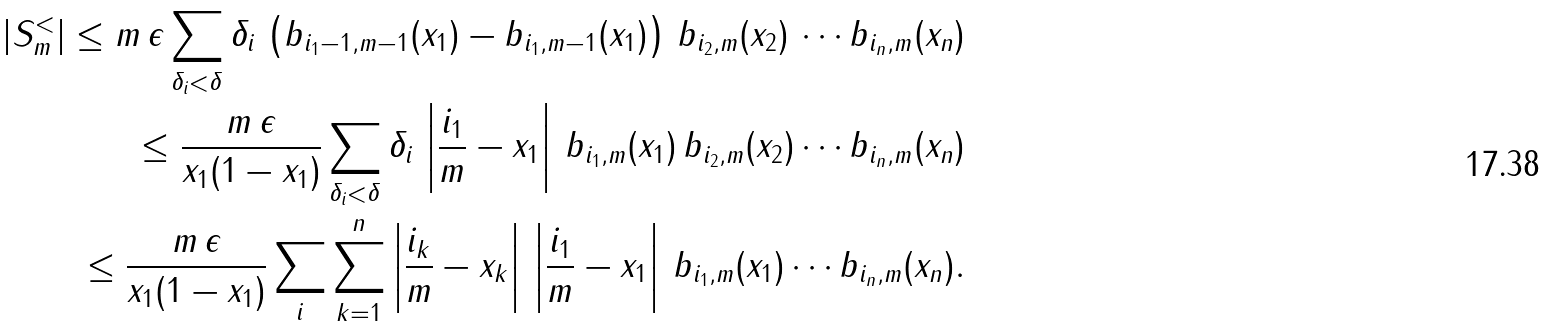<formula> <loc_0><loc_0><loc_500><loc_500>| S _ { m } ^ { < } | \leq m \, \epsilon \sum _ { \delta _ { i } < \delta } \delta _ { i } \, \left ( b _ { i _ { 1 } - 1 , m - 1 } ( x _ { 1 } ) - b _ { i _ { 1 } , m - 1 } ( x _ { 1 } ) \right ) \, b _ { i _ { 2 } , m } ( x _ { 2 } ) \, \cdots b _ { i _ { n } , m } ( x _ { n } ) \\ \leq \frac { m \, \epsilon } { x _ { 1 } ( 1 - x _ { 1 } ) } \sum _ { \delta _ { i } < \delta } \delta _ { i } \, \left | \frac { i _ { 1 } } { m } - x _ { 1 } \right | \, b _ { i _ { 1 } , m } ( x _ { 1 } ) \, b _ { i _ { 2 } , m } ( x _ { 2 } ) \cdots b _ { i _ { n } , m } ( x _ { n } ) \\ \leq \frac { m \, \epsilon } { x _ { 1 } ( 1 - x _ { 1 } ) } \sum _ { i } \sum _ { k = 1 } ^ { n } \left | \frac { i _ { k } } { m } - x _ { k } \right | \, \left | \frac { i _ { 1 } } { m } - x _ { 1 } \right | \, b _ { i _ { 1 } , m } ( x _ { 1 } ) \cdots b _ { i _ { n } , m } ( x _ { n } ) .</formula> 